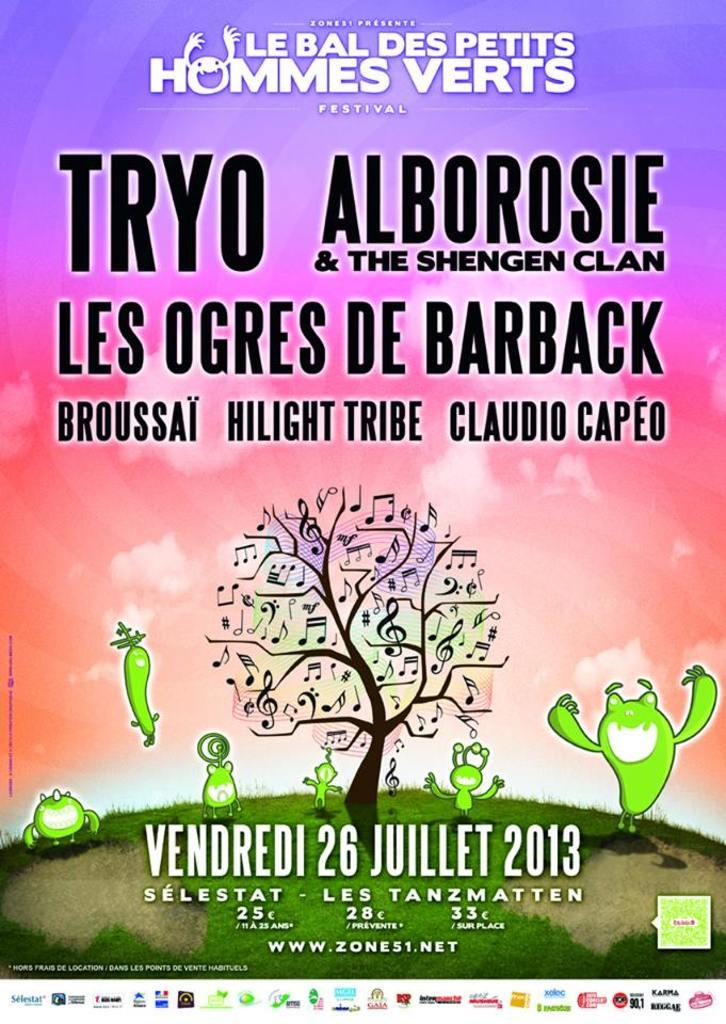What type of visual is the image? The image is a poster. What is depicted in the poster? There is a picture of a tree and a picture of grass on the poster. Is there any text on the poster? Yes, there is text on the poster. What type of nut is shown in the poster? There is no nut depicted in the poster; it features pictures of a tree and grass, along with text. Where can you find the lunchroom in the poster? There is no lunchroom present in the poster. 